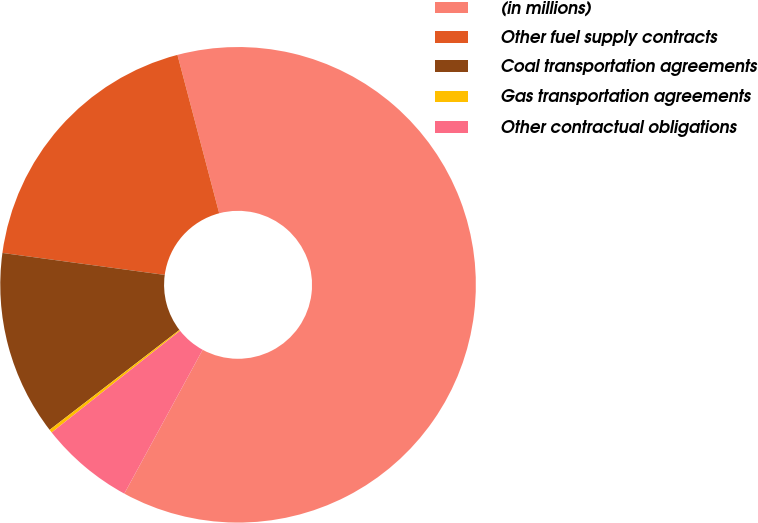<chart> <loc_0><loc_0><loc_500><loc_500><pie_chart><fcel>(in millions)<fcel>Other fuel supply contracts<fcel>Coal transportation agreements<fcel>Gas transportation agreements<fcel>Other contractual obligations<nl><fcel>62.04%<fcel>18.76%<fcel>12.58%<fcel>0.22%<fcel>6.4%<nl></chart> 